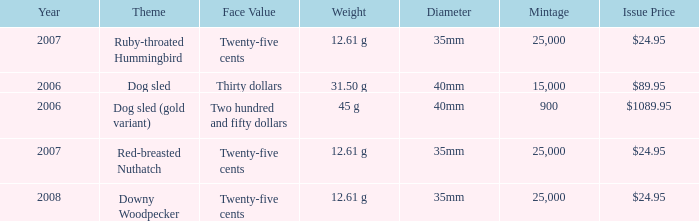What is the MIntage after 2006 of the Ruby-Throated Hummingbird Theme coin? 25000.0. 